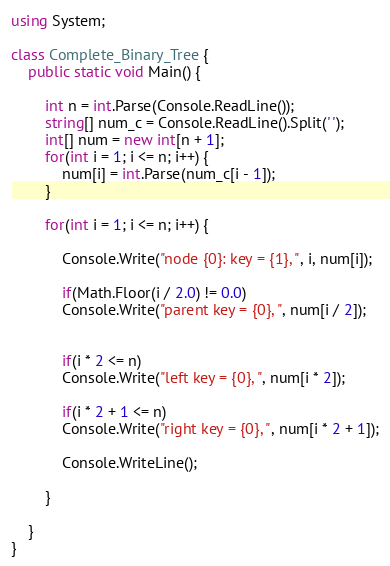<code> <loc_0><loc_0><loc_500><loc_500><_C#_>using System;

class Complete_Binary_Tree {
	public static void Main() {

		int n = int.Parse(Console.ReadLine());
		string[] num_c = Console.ReadLine().Split(' ');
		int[] num = new int[n + 1];
		for(int i = 1; i <= n; i++) {
			num[i] = int.Parse(num_c[i - 1]);
		}

		for(int i = 1; i <= n; i++) {

			Console.Write("node {0}: key = {1}, ", i, num[i]);

			if(Math.Floor(i / 2.0) != 0.0)
			Console.Write("parent key = {0}, ", num[i / 2]);
			

			if(i * 2 <= n)
			Console.Write("left key = {0}, ", num[i * 2]);

			if(i * 2 + 1 <= n)
			Console.Write("right key = {0}, ", num[i * 2 + 1]);

			Console.WriteLine();

		}

	}
}</code> 